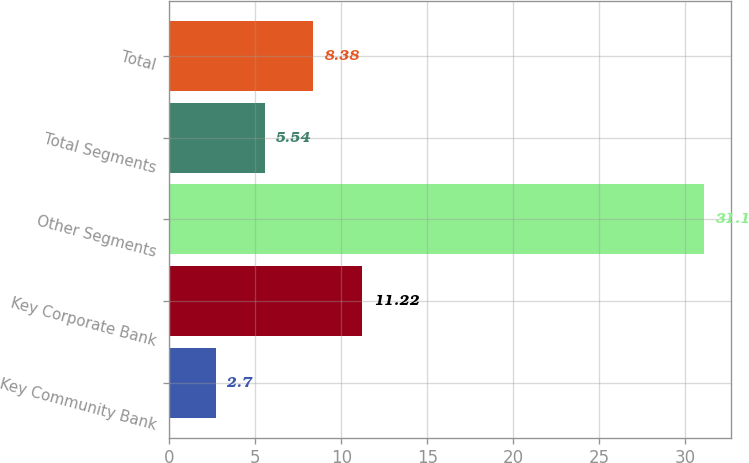Convert chart. <chart><loc_0><loc_0><loc_500><loc_500><bar_chart><fcel>Key Community Bank<fcel>Key Corporate Bank<fcel>Other Segments<fcel>Total Segments<fcel>Total<nl><fcel>2.7<fcel>11.22<fcel>31.1<fcel>5.54<fcel>8.38<nl></chart> 